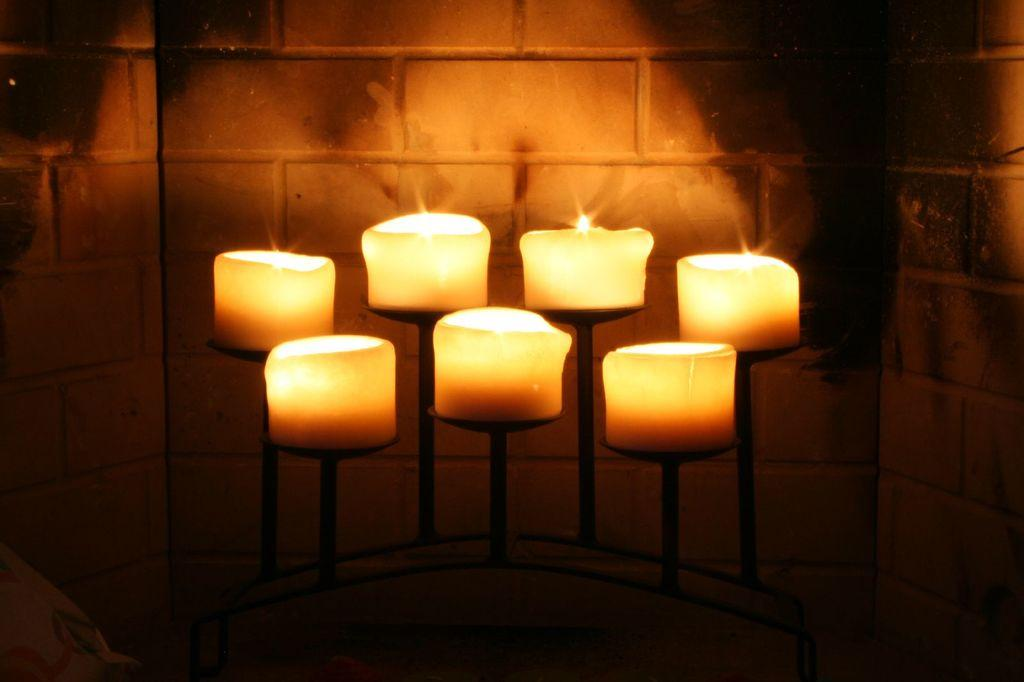What objects are on stands in the image? There are candles on stands in the image. What is located behind the candles? There is a wall behind the candles. Where is the tramp located in the image? There is no tramp present in the image. What type of cakes are displayed on the wall in the image? There are no cakes displayed on the wall in the image; only candles and a wall are present. 